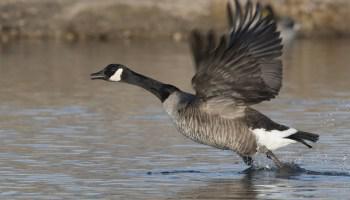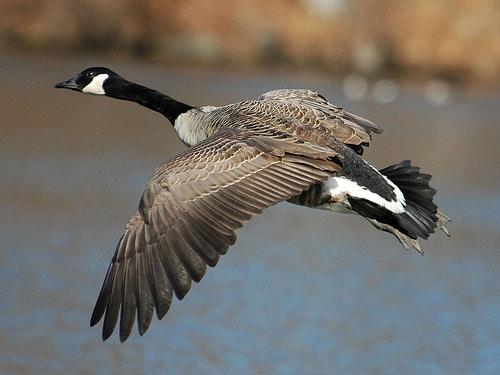The first image is the image on the left, the second image is the image on the right. For the images shown, is this caption "An image shows at least one baby gosling next to an adult goose." true? Answer yes or no. No. The first image is the image on the left, the second image is the image on the right. Analyze the images presented: Is the assertion "One image shows an adult Canada goose and at least one gosling, while the other image shows all adult Canada geese." valid? Answer yes or no. No. 